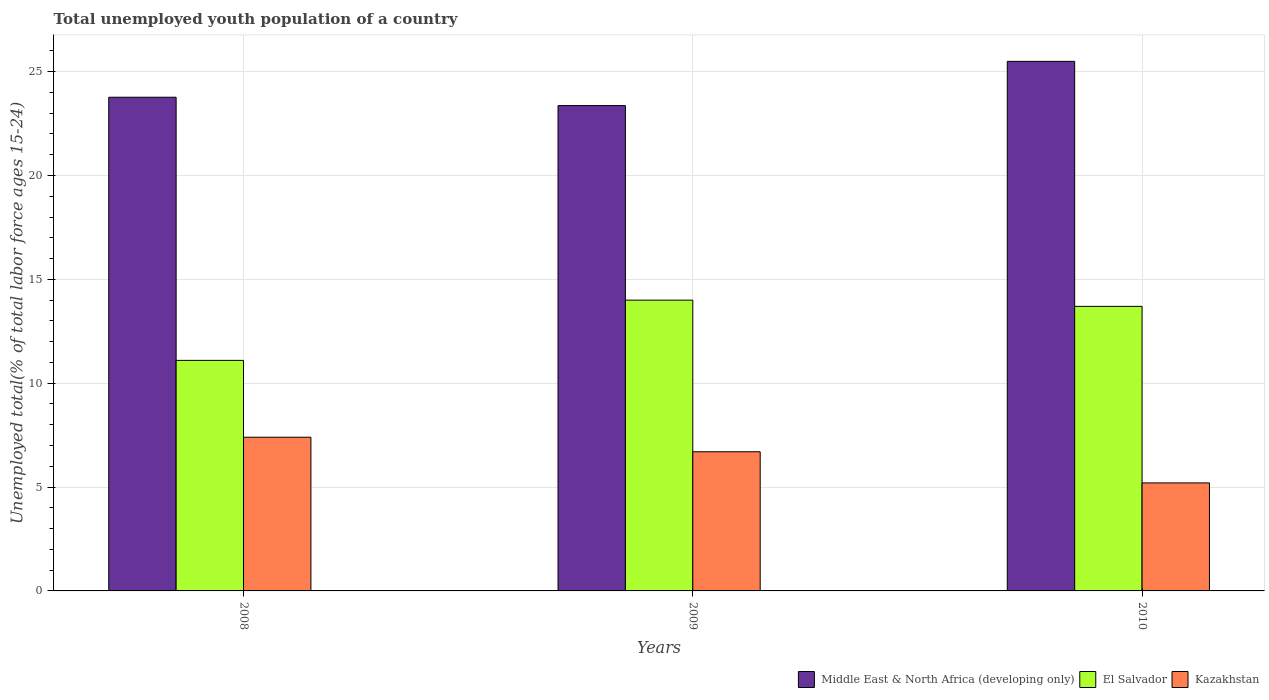Are the number of bars per tick equal to the number of legend labels?
Your answer should be very brief. Yes. Are the number of bars on each tick of the X-axis equal?
Offer a terse response. Yes. How many bars are there on the 3rd tick from the right?
Your response must be concise. 3. What is the label of the 3rd group of bars from the left?
Provide a succinct answer. 2010. In how many cases, is the number of bars for a given year not equal to the number of legend labels?
Your response must be concise. 0. What is the percentage of total unemployed youth population of a country in Middle East & North Africa (developing only) in 2010?
Offer a very short reply. 25.5. Across all years, what is the minimum percentage of total unemployed youth population of a country in Kazakhstan?
Give a very brief answer. 5.2. In which year was the percentage of total unemployed youth population of a country in El Salvador maximum?
Provide a succinct answer. 2009. In which year was the percentage of total unemployed youth population of a country in Middle East & North Africa (developing only) minimum?
Keep it short and to the point. 2009. What is the total percentage of total unemployed youth population of a country in Kazakhstan in the graph?
Provide a succinct answer. 19.3. What is the difference between the percentage of total unemployed youth population of a country in Kazakhstan in 2008 and that in 2009?
Your answer should be compact. 0.7. What is the difference between the percentage of total unemployed youth population of a country in El Salvador in 2008 and the percentage of total unemployed youth population of a country in Kazakhstan in 2010?
Your answer should be very brief. 5.9. What is the average percentage of total unemployed youth population of a country in Middle East & North Africa (developing only) per year?
Your answer should be compact. 24.21. In the year 2010, what is the difference between the percentage of total unemployed youth population of a country in El Salvador and percentage of total unemployed youth population of a country in Kazakhstan?
Give a very brief answer. 8.5. What is the ratio of the percentage of total unemployed youth population of a country in El Salvador in 2008 to that in 2010?
Offer a terse response. 0.81. What is the difference between the highest and the second highest percentage of total unemployed youth population of a country in Middle East & North Africa (developing only)?
Provide a short and direct response. 1.73. What is the difference between the highest and the lowest percentage of total unemployed youth population of a country in Middle East & North Africa (developing only)?
Make the answer very short. 2.13. In how many years, is the percentage of total unemployed youth population of a country in Kazakhstan greater than the average percentage of total unemployed youth population of a country in Kazakhstan taken over all years?
Make the answer very short. 2. What does the 2nd bar from the left in 2009 represents?
Provide a short and direct response. El Salvador. What does the 3rd bar from the right in 2008 represents?
Make the answer very short. Middle East & North Africa (developing only). How many bars are there?
Your response must be concise. 9. How many years are there in the graph?
Ensure brevity in your answer.  3. What is the difference between two consecutive major ticks on the Y-axis?
Your response must be concise. 5. Does the graph contain any zero values?
Keep it short and to the point. No. How many legend labels are there?
Make the answer very short. 3. How are the legend labels stacked?
Ensure brevity in your answer.  Horizontal. What is the title of the graph?
Ensure brevity in your answer.  Total unemployed youth population of a country. What is the label or title of the Y-axis?
Offer a very short reply. Unemployed total(% of total labor force ages 15-24). What is the Unemployed total(% of total labor force ages 15-24) in Middle East & North Africa (developing only) in 2008?
Offer a very short reply. 23.77. What is the Unemployed total(% of total labor force ages 15-24) of El Salvador in 2008?
Ensure brevity in your answer.  11.1. What is the Unemployed total(% of total labor force ages 15-24) in Kazakhstan in 2008?
Make the answer very short. 7.4. What is the Unemployed total(% of total labor force ages 15-24) of Middle East & North Africa (developing only) in 2009?
Your answer should be very brief. 23.37. What is the Unemployed total(% of total labor force ages 15-24) of El Salvador in 2009?
Ensure brevity in your answer.  14. What is the Unemployed total(% of total labor force ages 15-24) in Kazakhstan in 2009?
Offer a terse response. 6.7. What is the Unemployed total(% of total labor force ages 15-24) of Middle East & North Africa (developing only) in 2010?
Provide a succinct answer. 25.5. What is the Unemployed total(% of total labor force ages 15-24) in El Salvador in 2010?
Ensure brevity in your answer.  13.7. What is the Unemployed total(% of total labor force ages 15-24) of Kazakhstan in 2010?
Your answer should be compact. 5.2. Across all years, what is the maximum Unemployed total(% of total labor force ages 15-24) of Middle East & North Africa (developing only)?
Ensure brevity in your answer.  25.5. Across all years, what is the maximum Unemployed total(% of total labor force ages 15-24) of El Salvador?
Keep it short and to the point. 14. Across all years, what is the maximum Unemployed total(% of total labor force ages 15-24) in Kazakhstan?
Offer a terse response. 7.4. Across all years, what is the minimum Unemployed total(% of total labor force ages 15-24) in Middle East & North Africa (developing only)?
Your response must be concise. 23.37. Across all years, what is the minimum Unemployed total(% of total labor force ages 15-24) in El Salvador?
Make the answer very short. 11.1. Across all years, what is the minimum Unemployed total(% of total labor force ages 15-24) of Kazakhstan?
Ensure brevity in your answer.  5.2. What is the total Unemployed total(% of total labor force ages 15-24) of Middle East & North Africa (developing only) in the graph?
Your answer should be compact. 72.63. What is the total Unemployed total(% of total labor force ages 15-24) of El Salvador in the graph?
Offer a terse response. 38.8. What is the total Unemployed total(% of total labor force ages 15-24) of Kazakhstan in the graph?
Offer a very short reply. 19.3. What is the difference between the Unemployed total(% of total labor force ages 15-24) of Middle East & North Africa (developing only) in 2008 and that in 2009?
Keep it short and to the point. 0.4. What is the difference between the Unemployed total(% of total labor force ages 15-24) in El Salvador in 2008 and that in 2009?
Keep it short and to the point. -2.9. What is the difference between the Unemployed total(% of total labor force ages 15-24) of Kazakhstan in 2008 and that in 2009?
Offer a terse response. 0.7. What is the difference between the Unemployed total(% of total labor force ages 15-24) in Middle East & North Africa (developing only) in 2008 and that in 2010?
Your response must be concise. -1.73. What is the difference between the Unemployed total(% of total labor force ages 15-24) of Middle East & North Africa (developing only) in 2009 and that in 2010?
Your answer should be very brief. -2.13. What is the difference between the Unemployed total(% of total labor force ages 15-24) in El Salvador in 2009 and that in 2010?
Offer a terse response. 0.3. What is the difference between the Unemployed total(% of total labor force ages 15-24) in Kazakhstan in 2009 and that in 2010?
Your answer should be compact. 1.5. What is the difference between the Unemployed total(% of total labor force ages 15-24) of Middle East & North Africa (developing only) in 2008 and the Unemployed total(% of total labor force ages 15-24) of El Salvador in 2009?
Your answer should be very brief. 9.77. What is the difference between the Unemployed total(% of total labor force ages 15-24) in Middle East & North Africa (developing only) in 2008 and the Unemployed total(% of total labor force ages 15-24) in Kazakhstan in 2009?
Ensure brevity in your answer.  17.07. What is the difference between the Unemployed total(% of total labor force ages 15-24) of Middle East & North Africa (developing only) in 2008 and the Unemployed total(% of total labor force ages 15-24) of El Salvador in 2010?
Offer a terse response. 10.07. What is the difference between the Unemployed total(% of total labor force ages 15-24) of Middle East & North Africa (developing only) in 2008 and the Unemployed total(% of total labor force ages 15-24) of Kazakhstan in 2010?
Give a very brief answer. 18.57. What is the difference between the Unemployed total(% of total labor force ages 15-24) in El Salvador in 2008 and the Unemployed total(% of total labor force ages 15-24) in Kazakhstan in 2010?
Your answer should be compact. 5.9. What is the difference between the Unemployed total(% of total labor force ages 15-24) in Middle East & North Africa (developing only) in 2009 and the Unemployed total(% of total labor force ages 15-24) in El Salvador in 2010?
Make the answer very short. 9.67. What is the difference between the Unemployed total(% of total labor force ages 15-24) in Middle East & North Africa (developing only) in 2009 and the Unemployed total(% of total labor force ages 15-24) in Kazakhstan in 2010?
Keep it short and to the point. 18.17. What is the average Unemployed total(% of total labor force ages 15-24) of Middle East & North Africa (developing only) per year?
Your response must be concise. 24.21. What is the average Unemployed total(% of total labor force ages 15-24) in El Salvador per year?
Offer a very short reply. 12.93. What is the average Unemployed total(% of total labor force ages 15-24) of Kazakhstan per year?
Your response must be concise. 6.43. In the year 2008, what is the difference between the Unemployed total(% of total labor force ages 15-24) in Middle East & North Africa (developing only) and Unemployed total(% of total labor force ages 15-24) in El Salvador?
Provide a succinct answer. 12.67. In the year 2008, what is the difference between the Unemployed total(% of total labor force ages 15-24) of Middle East & North Africa (developing only) and Unemployed total(% of total labor force ages 15-24) of Kazakhstan?
Provide a succinct answer. 16.37. In the year 2009, what is the difference between the Unemployed total(% of total labor force ages 15-24) of Middle East & North Africa (developing only) and Unemployed total(% of total labor force ages 15-24) of El Salvador?
Ensure brevity in your answer.  9.37. In the year 2009, what is the difference between the Unemployed total(% of total labor force ages 15-24) in Middle East & North Africa (developing only) and Unemployed total(% of total labor force ages 15-24) in Kazakhstan?
Your answer should be compact. 16.67. In the year 2009, what is the difference between the Unemployed total(% of total labor force ages 15-24) in El Salvador and Unemployed total(% of total labor force ages 15-24) in Kazakhstan?
Ensure brevity in your answer.  7.3. In the year 2010, what is the difference between the Unemployed total(% of total labor force ages 15-24) of Middle East & North Africa (developing only) and Unemployed total(% of total labor force ages 15-24) of El Salvador?
Your answer should be compact. 11.8. In the year 2010, what is the difference between the Unemployed total(% of total labor force ages 15-24) of Middle East & North Africa (developing only) and Unemployed total(% of total labor force ages 15-24) of Kazakhstan?
Provide a succinct answer. 20.3. In the year 2010, what is the difference between the Unemployed total(% of total labor force ages 15-24) in El Salvador and Unemployed total(% of total labor force ages 15-24) in Kazakhstan?
Provide a succinct answer. 8.5. What is the ratio of the Unemployed total(% of total labor force ages 15-24) of Middle East & North Africa (developing only) in 2008 to that in 2009?
Ensure brevity in your answer.  1.02. What is the ratio of the Unemployed total(% of total labor force ages 15-24) in El Salvador in 2008 to that in 2009?
Make the answer very short. 0.79. What is the ratio of the Unemployed total(% of total labor force ages 15-24) of Kazakhstan in 2008 to that in 2009?
Your answer should be very brief. 1.1. What is the ratio of the Unemployed total(% of total labor force ages 15-24) of Middle East & North Africa (developing only) in 2008 to that in 2010?
Your answer should be very brief. 0.93. What is the ratio of the Unemployed total(% of total labor force ages 15-24) in El Salvador in 2008 to that in 2010?
Ensure brevity in your answer.  0.81. What is the ratio of the Unemployed total(% of total labor force ages 15-24) of Kazakhstan in 2008 to that in 2010?
Offer a very short reply. 1.42. What is the ratio of the Unemployed total(% of total labor force ages 15-24) in Middle East & North Africa (developing only) in 2009 to that in 2010?
Offer a very short reply. 0.92. What is the ratio of the Unemployed total(% of total labor force ages 15-24) of El Salvador in 2009 to that in 2010?
Give a very brief answer. 1.02. What is the ratio of the Unemployed total(% of total labor force ages 15-24) in Kazakhstan in 2009 to that in 2010?
Make the answer very short. 1.29. What is the difference between the highest and the second highest Unemployed total(% of total labor force ages 15-24) in Middle East & North Africa (developing only)?
Your answer should be very brief. 1.73. What is the difference between the highest and the lowest Unemployed total(% of total labor force ages 15-24) in Middle East & North Africa (developing only)?
Ensure brevity in your answer.  2.13. What is the difference between the highest and the lowest Unemployed total(% of total labor force ages 15-24) in Kazakhstan?
Make the answer very short. 2.2. 